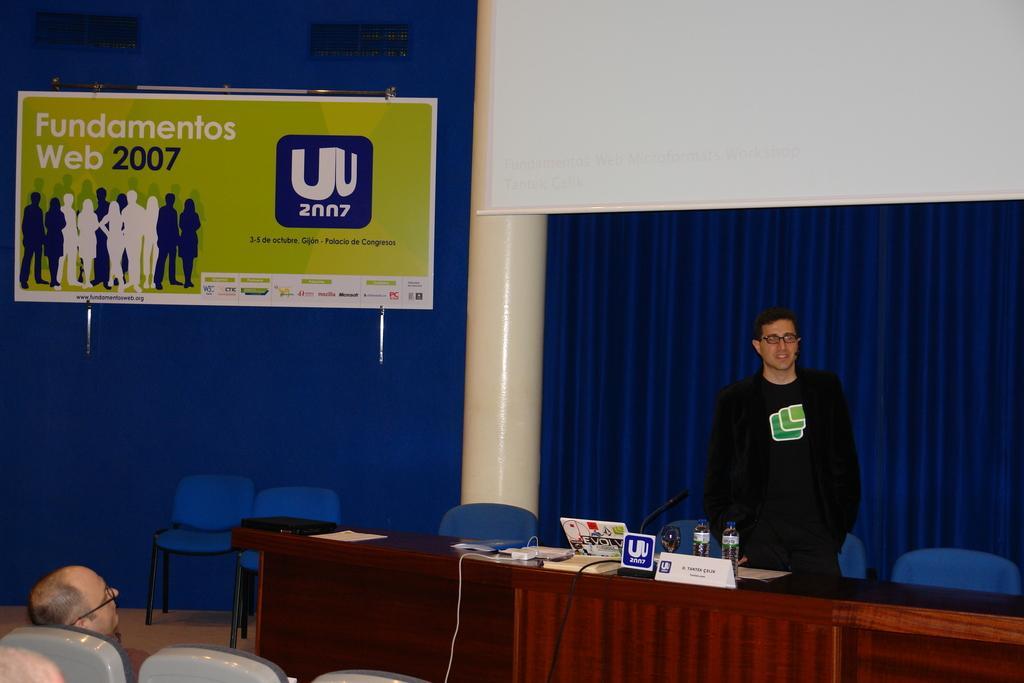Can you describe this image briefly? This person standing. On the background we can see pillar,curtains,white board,poster. We can see chairs. There is a table. On the table we can see bottle,name board,microphone,cable. These two person sitting on the chair. 